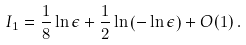Convert formula to latex. <formula><loc_0><loc_0><loc_500><loc_500>I _ { 1 } = \frac { 1 } { 8 } \ln \epsilon + \frac { 1 } { 2 } \ln \left ( - \ln \epsilon \right ) + O ( 1 ) \, .</formula> 